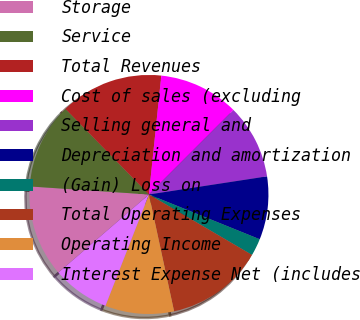<chart> <loc_0><loc_0><loc_500><loc_500><pie_chart><fcel>Storage<fcel>Service<fcel>Total Revenues<fcel>Cost of sales (excluding<fcel>Selling general and<fcel>Depreciation and amortization<fcel>(Gain) Loss on<fcel>Total Operating Expenses<fcel>Operating Income<fcel>Interest Expense Net (includes<nl><fcel>12.4%<fcel>11.63%<fcel>13.95%<fcel>10.85%<fcel>10.08%<fcel>8.53%<fcel>2.33%<fcel>13.18%<fcel>9.3%<fcel>7.75%<nl></chart> 